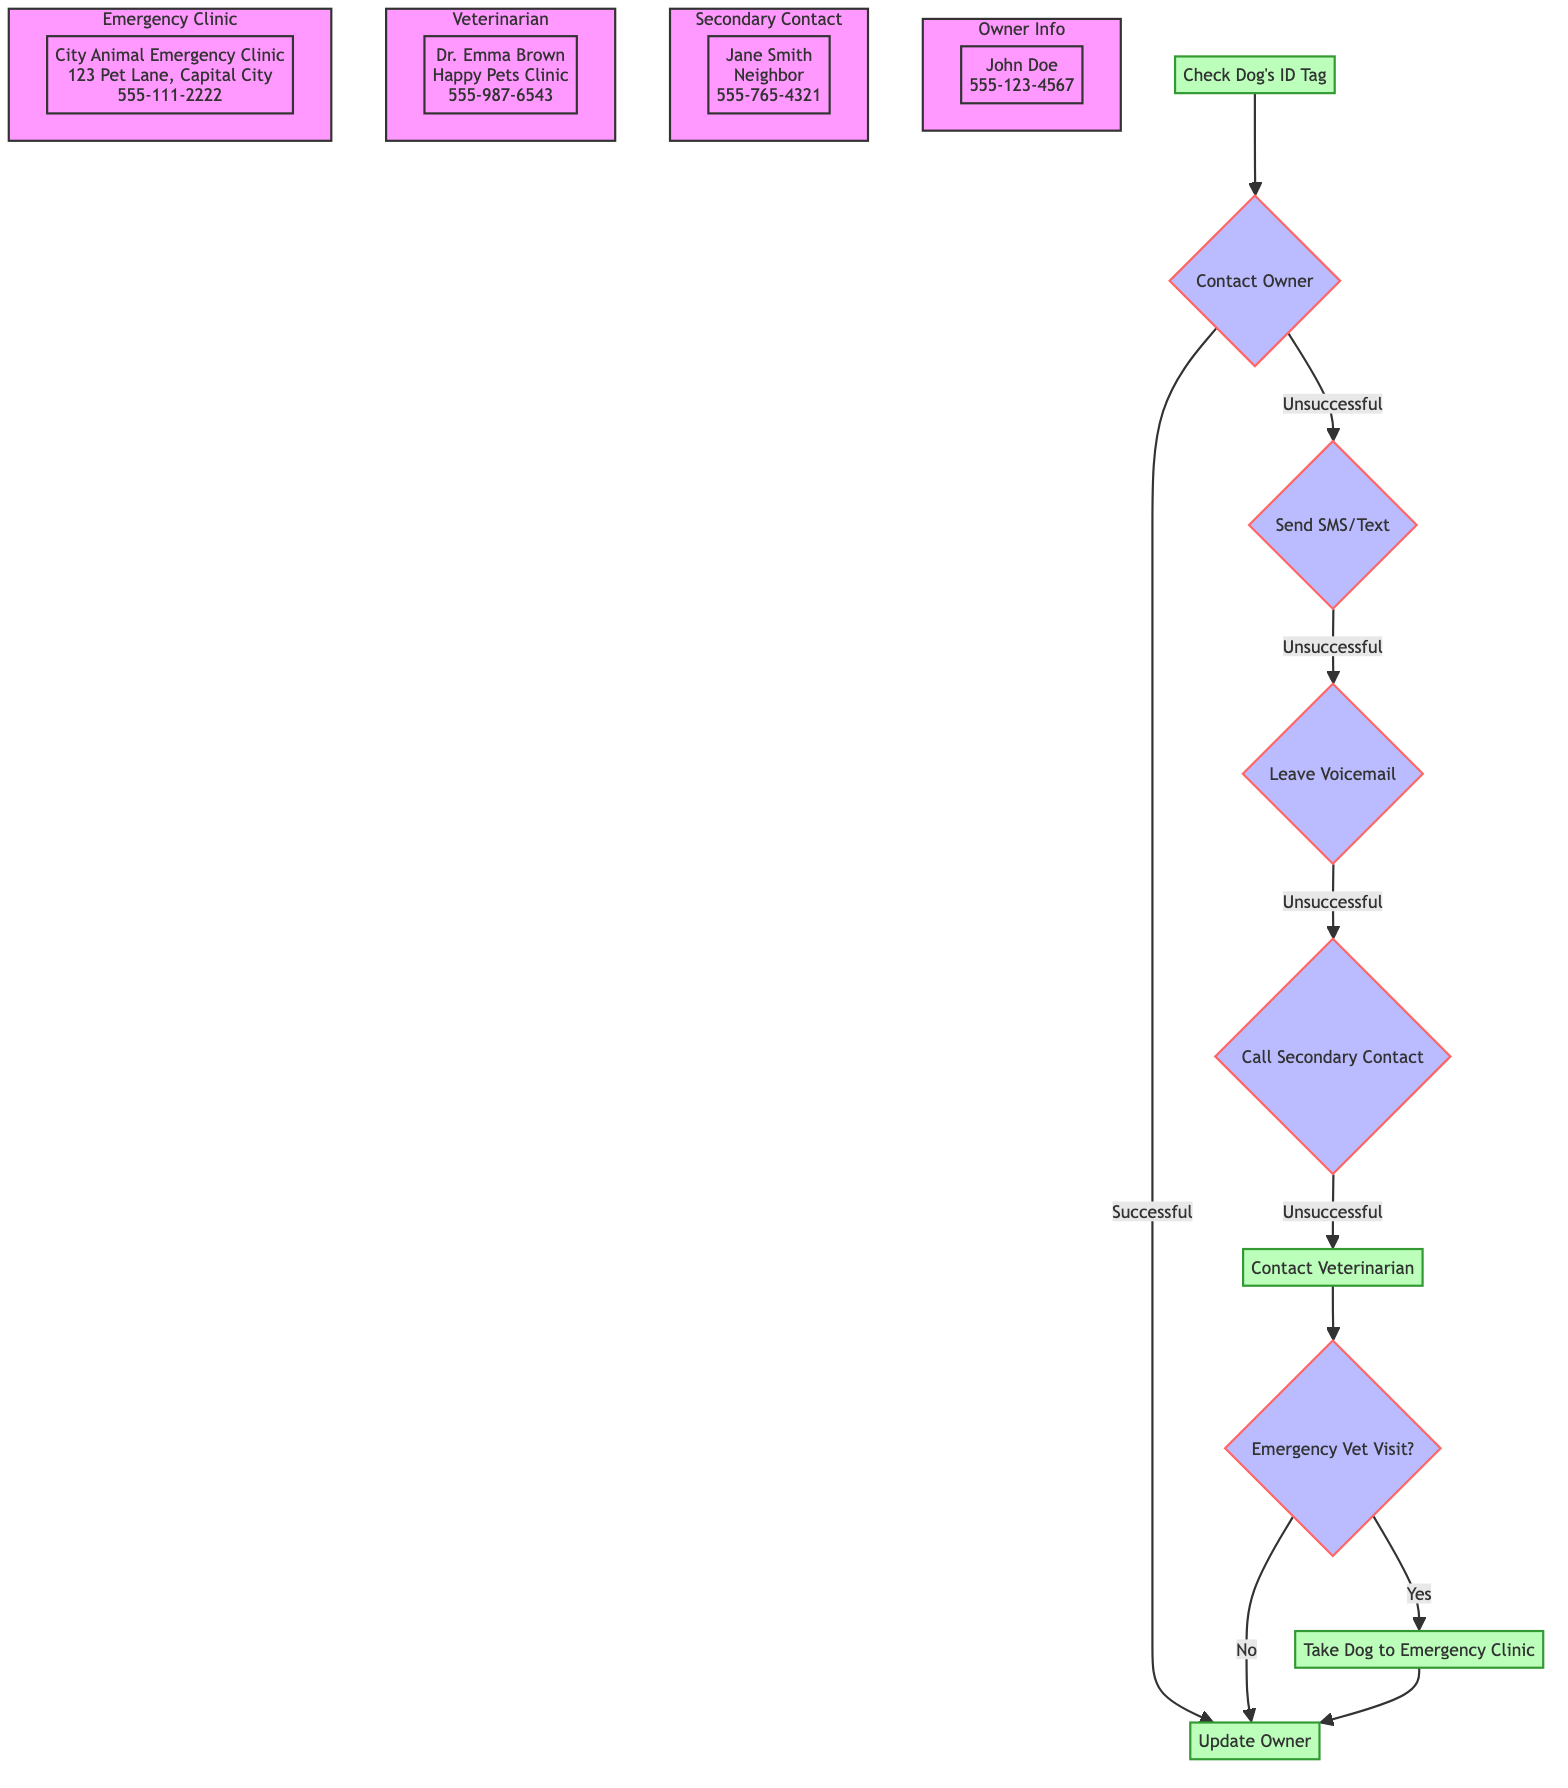What is the first step in the Emergency Contact Protocol? The first step is "Check Dog's ID Tag," which is where the dog walker begins the emergency process by reviewing the dog's ID tag for immediate contact information.
Answer: Check Dog's ID Tag How many alternative actions are there if the dog walker cannot contact the owner? There are three alternative actions listed if the dog walker cannot get in touch with the owner. They include sending an SMS/Text, leaving a voicemail, and calling a secondary contact.
Answer: Three What action is taken if the owner is unreachable after trying all alternative actions? If the owner is unreachable after all alternative actions, the next action taken is to "Contact Veterinarian," indicating that the dog walker is moving on to the next step in the protocol.
Answer: Contact Veterinarian What is the veterinarian's name listed in the diagram? The veterinarian's name is "Dr. Emma Brown," as specified in the diagram under the veterinarian section.
Answer: Dr. Emma Brown How is the dog walker informed about whether to take the dog to an emergency veterinary clinic? The decision to take the dog to an emergency veterinary clinic is based on a question labeled "Emergency Vet Visit?", which requires a yes or no answer directing the next step after contacting the veterinarian.
Answer: Emergency Vet Visit? If directed, what is the name of the emergency clinic the dog should be taken to? The name of the emergency veterinary clinic is "City Animal Emergency Clinic," which is listed in the emergency vet visit step.
Answer: City Animal Emergency Clinic What is the primary phone number for contacting the owner? The primary phone number for contacting the owner is "555-123-4567," as shown in the designated section for owner information.
Answer: 555-123-4567 Which node follows the "Call Secondary Contact" action if it is also unsuccessful? If the "Call Secondary Contact" action is also unsuccessful, the flow moves to the action node "Contact Veterinarian," indicating the next step in the protocol.
Answer: Contact Veterinarian What type of information is provided at the end of the "Update Owner" step? At the end of the "Update Owner" step, the dog walker informs the owner about the situation and actions taken, ensuring the owner is updated once they are reachable.
Answer: Inform the owner 